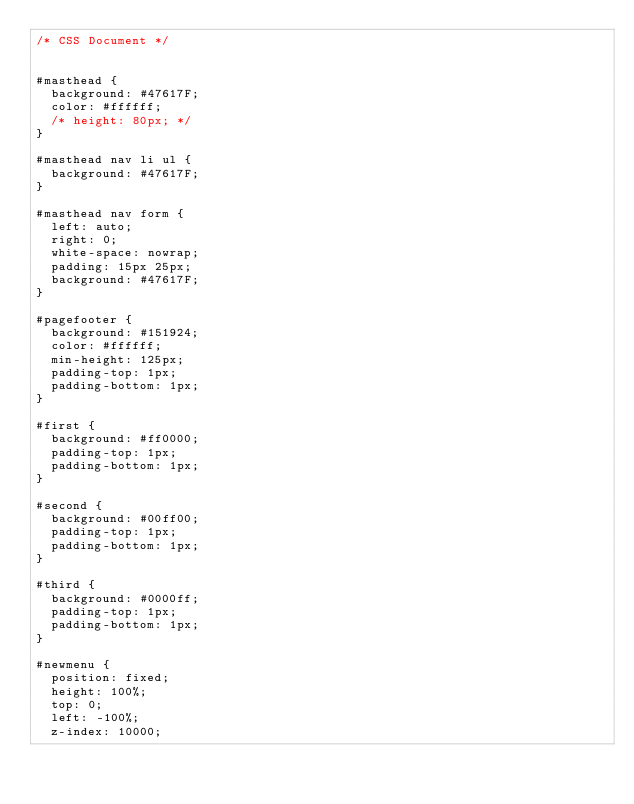Convert code to text. <code><loc_0><loc_0><loc_500><loc_500><_CSS_>/* CSS Document */


#masthead {
	background: #47617F;
	color: #ffffff;
	/* height: 80px; */
}

#masthead nav li ul {
	background: #47617F;
}

#masthead nav form {
	left: auto;
	right: 0;
	white-space: nowrap;
	padding: 15px 25px;
	background: #47617F;
}

#pagefooter {
	background: #151924;
	color: #ffffff;
	min-height: 125px;
	padding-top: 1px;
	padding-bottom: 1px;
}

#first {
	background: #ff0000;
	padding-top: 1px;
	padding-bottom: 1px;
}

#second {
	background: #00ff00;
	padding-top: 1px;
	padding-bottom: 1px;
}

#third {
	background: #0000ff;
	padding-top: 1px;
	padding-bottom: 1px;
}

#newmenu {
	position: fixed;
	height: 100%;
	top: 0;
	left: -100%;
	z-index: 10000;</code> 